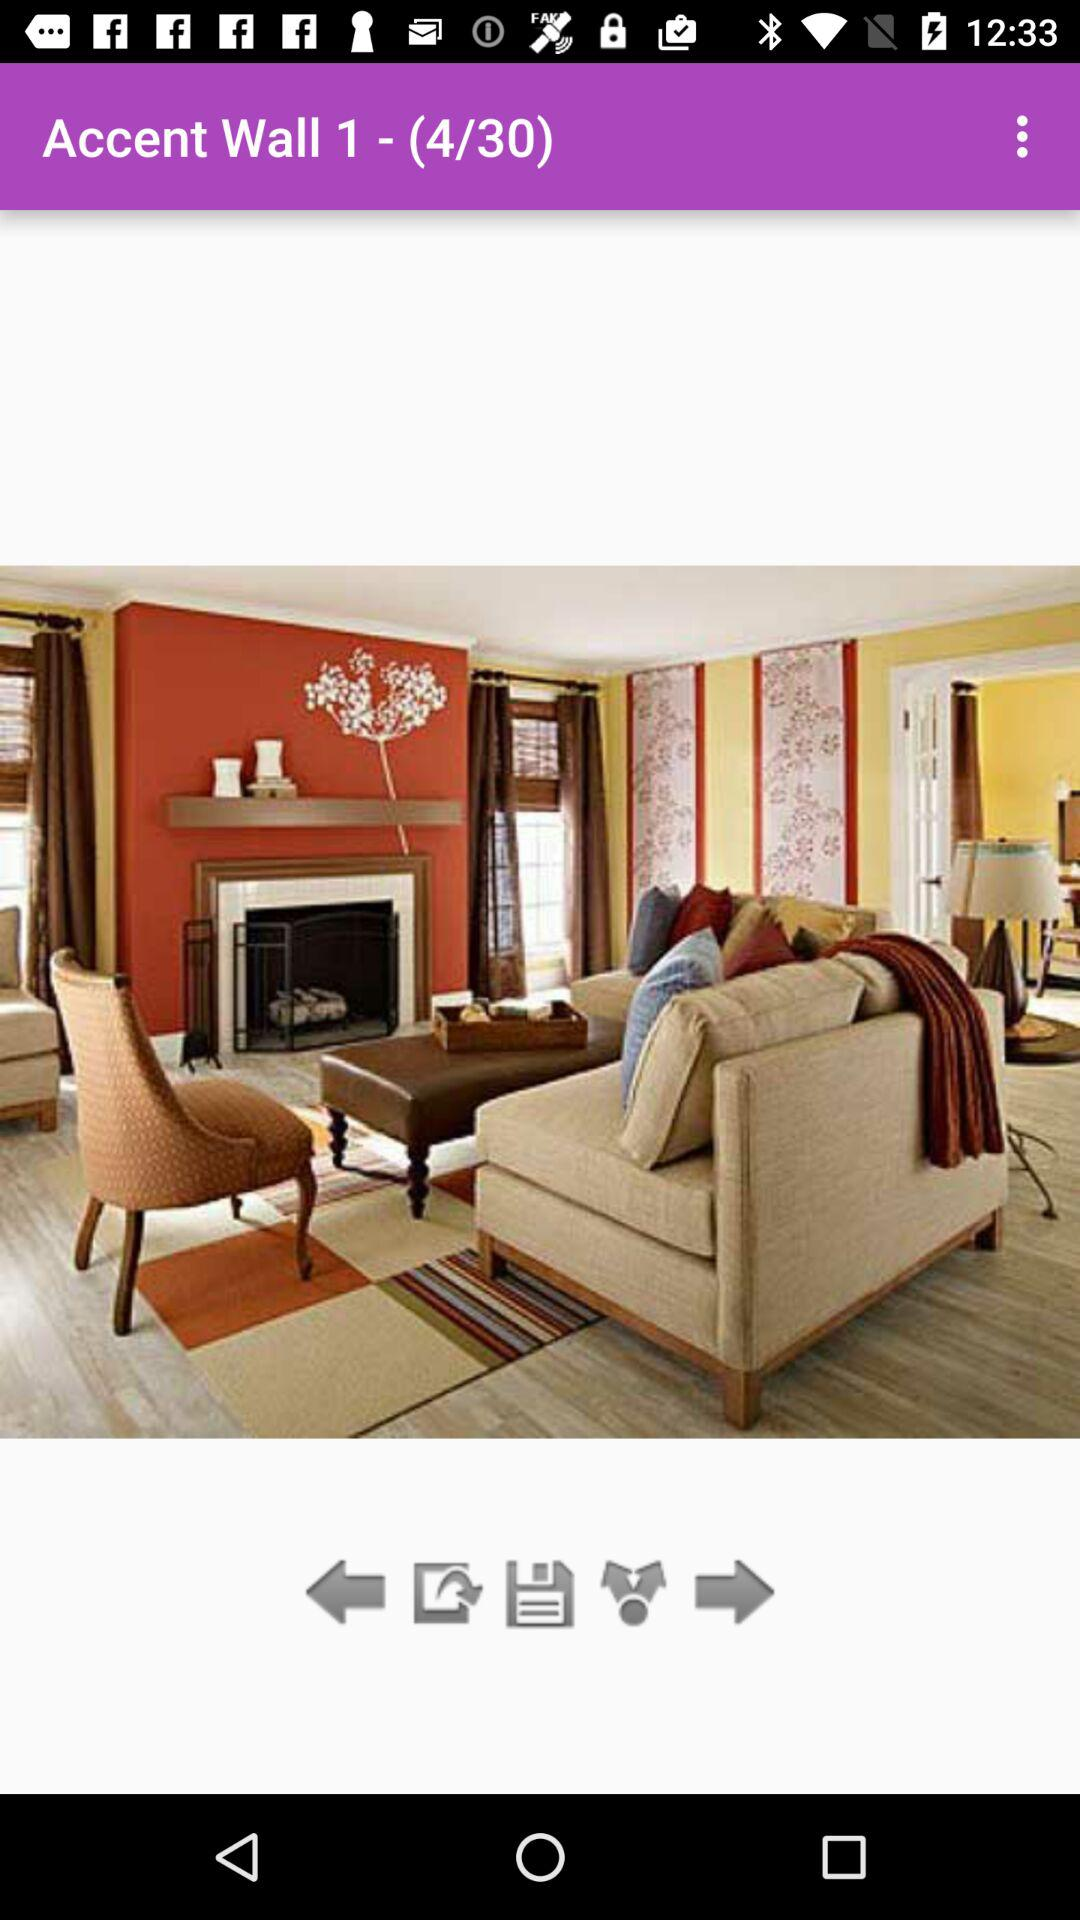Which photo is selected? The selected photo is 4. 